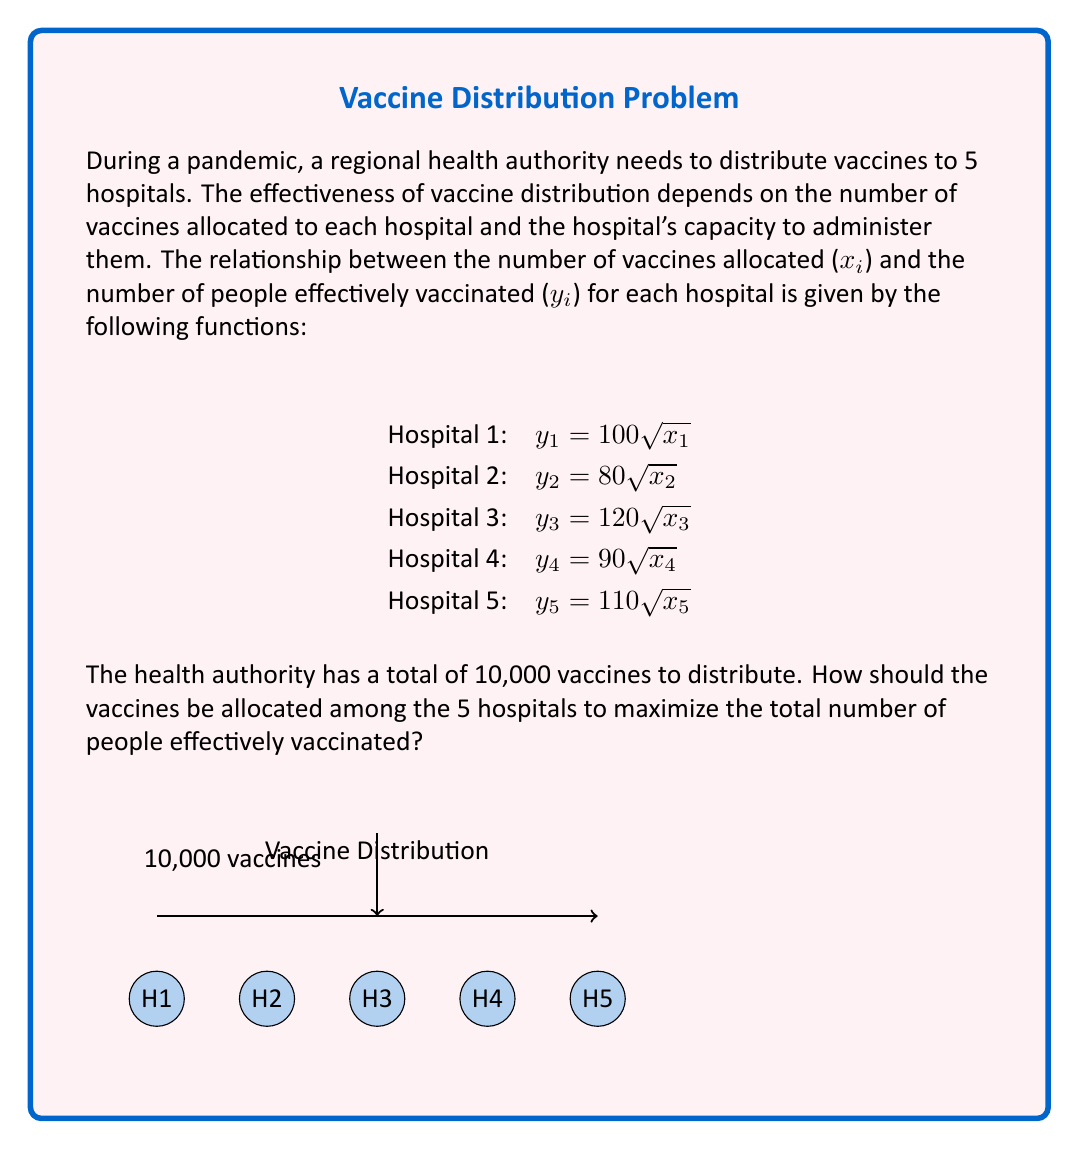Provide a solution to this math problem. To solve this optimization problem, we'll use the method of Lagrange multipliers:

1) Our objective function is the total number of people effectively vaccinated:
   $$f(x_1,x_2,x_3,x_4,x_5) = 100\sqrt{x_1} + 80\sqrt{x_2} + 120\sqrt{x_3} + 90\sqrt{x_4} + 110\sqrt{x_5}$$

2) The constraint is the total number of vaccines:
   $$g(x_1,x_2,x_3,x_4,x_5) = x_1 + x_2 + x_3 + x_4 + x_5 = 10000$$

3) We form the Lagrangian:
   $$L = f + \lambda g = 100\sqrt{x_1} + 80\sqrt{x_2} + 120\sqrt{x_3} + 90\sqrt{x_4} + 110\sqrt{x_5} + \lambda(x_1 + x_2 + x_3 + x_4 + x_5 - 10000)$$

4) We take partial derivatives and set them equal to zero:
   $$\frac{\partial L}{\partial x_1} = \frac{50}{\sqrt{x_1}} + \lambda = 0$$
   $$\frac{\partial L}{\partial x_2} = \frac{40}{\sqrt{x_2}} + \lambda = 0$$
   $$\frac{\partial L}{\partial x_3} = \frac{60}{\sqrt{x_3}} + \lambda = 0$$
   $$\frac{\partial L}{\partial x_4} = \frac{45}{\sqrt{x_4}} + \lambda = 0$$
   $$\frac{\partial L}{\partial x_5} = \frac{55}{\sqrt{x_5}} + \lambda = 0$$

5) From these equations, we can deduce:
   $$\frac{50}{\sqrt{x_1}} = \frac{40}{\sqrt{x_2}} = \frac{60}{\sqrt{x_3}} = \frac{45}{\sqrt{x_4}} = \frac{55}{\sqrt{x_5}} = -\lambda$$

6) This implies:
   $$x_1 : x_2 : x_3 : x_4 : x_5 = 50^2 : 40^2 : 60^2 : 45^2 : 55^2 = 2500 : 1600 : 3600 : 2025 : 3025$$

7) The sum of these ratios is 12750. We need to distribute 10000 vaccines, so we multiply each ratio by 10000/12750:

   $$x_1 = \frac{2500}{12750} \cdot 10000 \approx 1961$$
   $$x_2 = \frac{1600}{12750} \cdot 10000 \approx 1255$$
   $$x_3 = \frac{3600}{12750} \cdot 10000 \approx 2824$$
   $$x_4 = \frac{2025}{12750} \cdot 10000 \approx 1588$$
   $$x_5 = \frac{3025}{12750} \cdot 10000 \approx 2372$$

These are the optimal allocations for each hospital to maximize the total number of people effectively vaccinated.
Answer: Hospital 1: 1961, Hospital 2: 1255, Hospital 3: 2824, Hospital 4: 1588, Hospital 5: 2372 